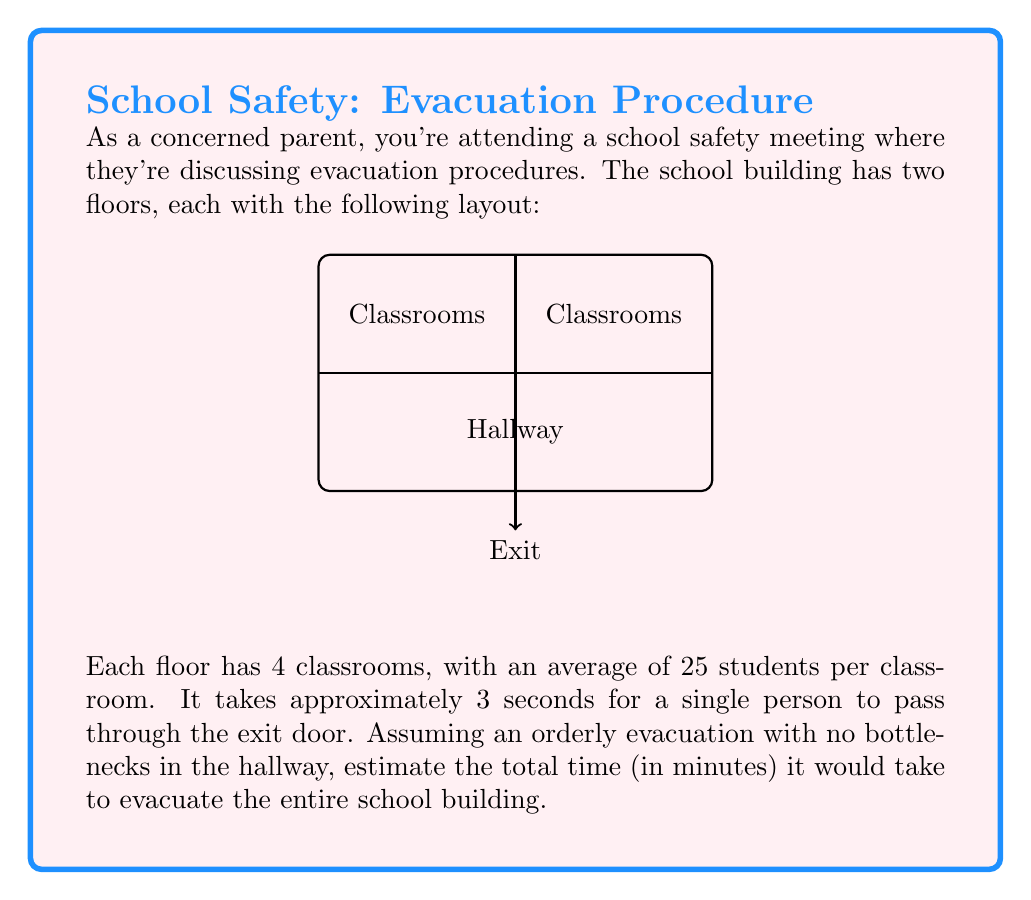What is the answer to this math problem? Let's break this down step-by-step:

1. Calculate the total number of students in the building:
   - Each floor has 4 classrooms with 25 students each
   - Number of students per floor = $4 \times 25 = 100$
   - Total students in two floors = $100 \times 2 = 200$ students

2. Calculate the total time for all students to pass through the exit:
   - Time per student = 3 seconds
   - Total time = $200 \text{ students} \times 3 \text{ seconds} = 600 \text{ seconds}$

3. Convert seconds to minutes:
   $$\text{Time in minutes} = \frac{600 \text{ seconds}}{60 \text{ seconds/minute}} = 10 \text{ minutes}$$

Therefore, it would take approximately 10 minutes to evacuate the entire school building under these conditions.

Note: This estimation assumes perfect conditions. In reality, factors such as stairway congestion, potential panic, or the presence of teachers and staff might increase the evacuation time. As a concerned parent, it's important to discuss these factors with school administrators to ensure comprehensive safety planning.
Answer: 10 minutes 